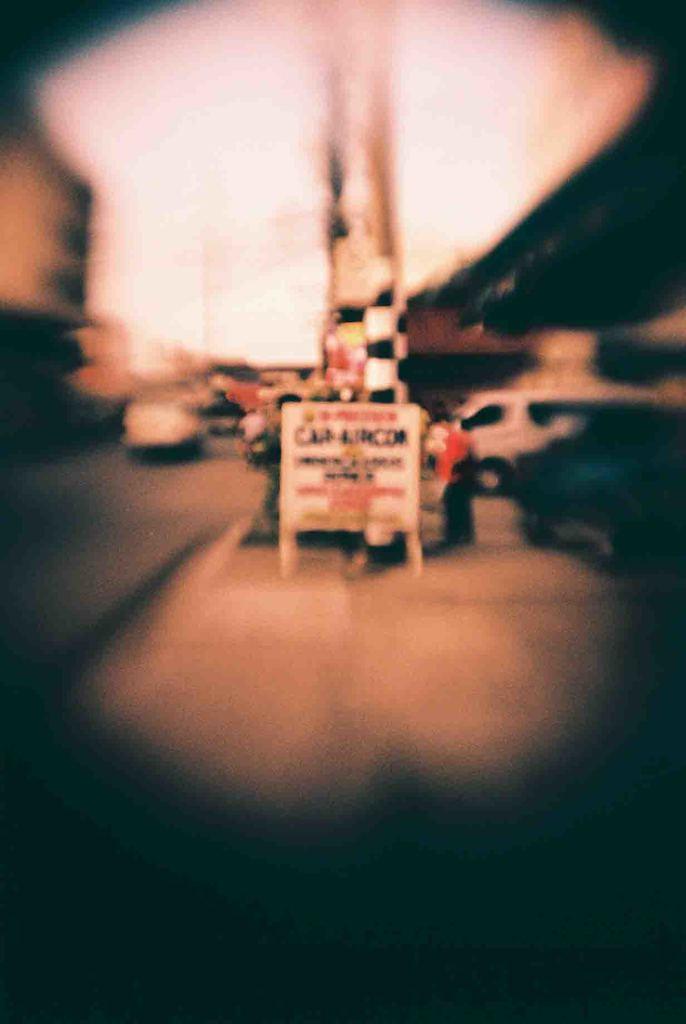Please provide a concise description of this image. In the image we can see some vehicles on the road and there is a banner. Behind the banner few people are standing and the image is blur. 